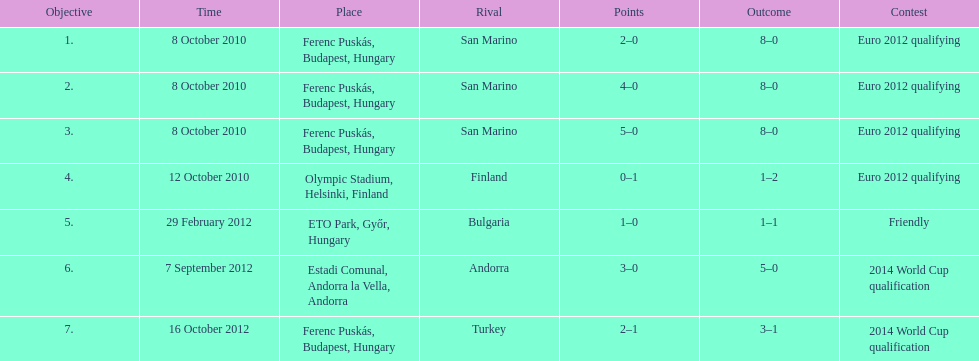In how many games that were not qualifying matches did he score? 1. Parse the full table. {'header': ['Objective', 'Time', 'Place', 'Rival', 'Points', 'Outcome', 'Contest'], 'rows': [['1.', '8 October 2010', 'Ferenc Puskás, Budapest, Hungary', 'San Marino', '2–0', '8–0', 'Euro 2012 qualifying'], ['2.', '8 October 2010', 'Ferenc Puskás, Budapest, Hungary', 'San Marino', '4–0', '8–0', 'Euro 2012 qualifying'], ['3.', '8 October 2010', 'Ferenc Puskás, Budapest, Hungary', 'San Marino', '5–0', '8–0', 'Euro 2012 qualifying'], ['4.', '12 October 2010', 'Olympic Stadium, Helsinki, Finland', 'Finland', '0–1', '1–2', 'Euro 2012 qualifying'], ['5.', '29 February 2012', 'ETO Park, Győr, Hungary', 'Bulgaria', '1–0', '1–1', 'Friendly'], ['6.', '7 September 2012', 'Estadi Comunal, Andorra la Vella, Andorra', 'Andorra', '3–0', '5–0', '2014 World Cup qualification'], ['7.', '16 October 2012', 'Ferenc Puskás, Budapest, Hungary', 'Turkey', '2–1', '3–1', '2014 World Cup qualification']]} 